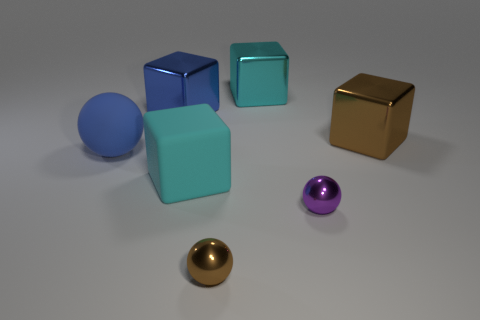Subtract all big blue blocks. How many blocks are left? 3 Add 2 big green metal cylinders. How many objects exist? 9 Subtract all brown spheres. How many spheres are left? 2 Subtract all blocks. How many objects are left? 3 Add 2 big metallic blocks. How many big metallic blocks are left? 5 Add 1 large cyan matte objects. How many large cyan matte objects exist? 2 Subtract 0 gray cylinders. How many objects are left? 7 Subtract 1 spheres. How many spheres are left? 2 Subtract all yellow cubes. Subtract all cyan spheres. How many cubes are left? 4 Subtract all yellow blocks. How many blue balls are left? 1 